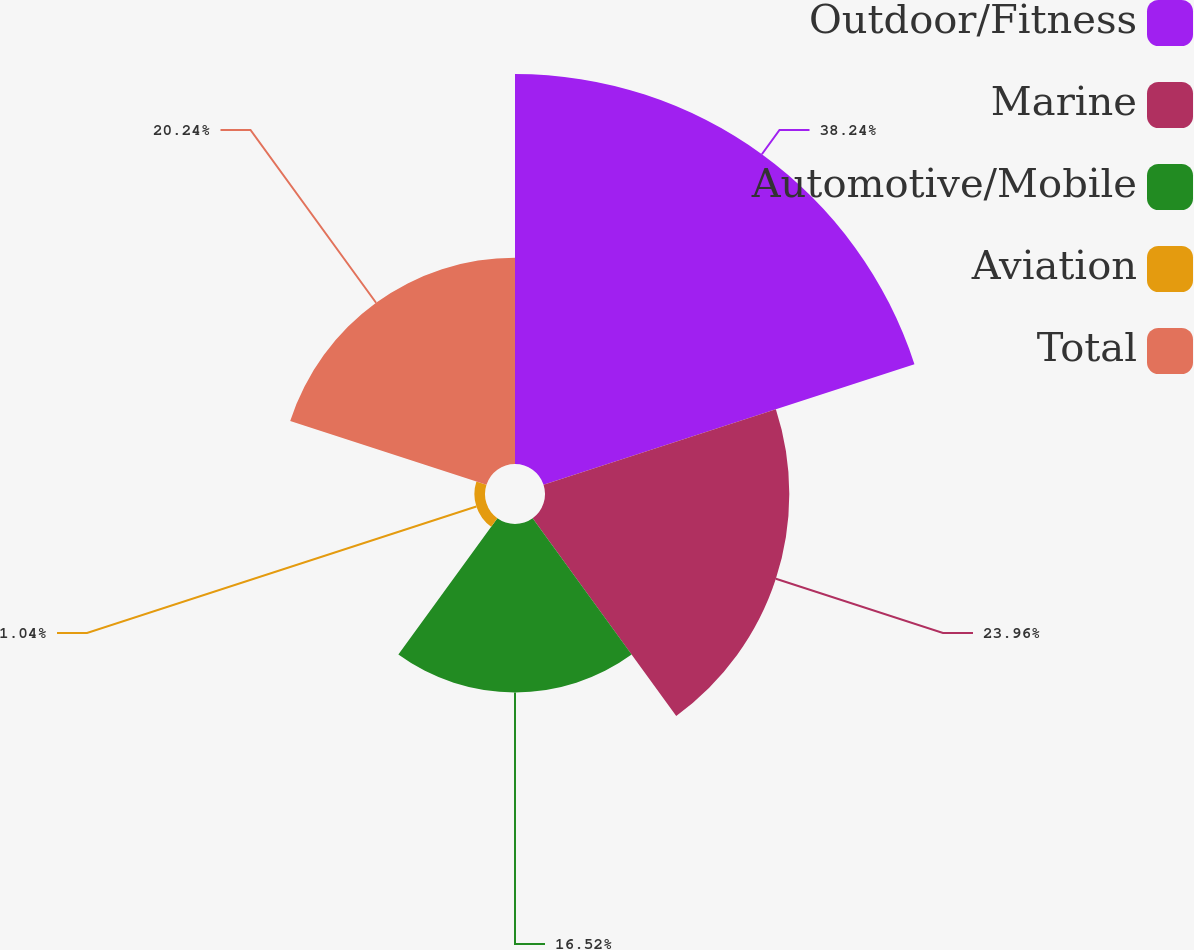Convert chart. <chart><loc_0><loc_0><loc_500><loc_500><pie_chart><fcel>Outdoor/Fitness<fcel>Marine<fcel>Automotive/Mobile<fcel>Aviation<fcel>Total<nl><fcel>38.25%<fcel>23.96%<fcel>16.52%<fcel>1.04%<fcel>20.24%<nl></chart> 